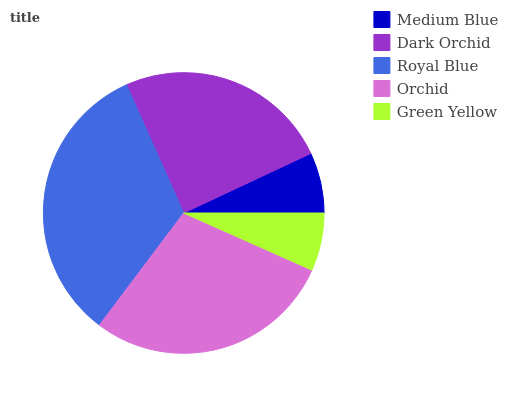Is Green Yellow the minimum?
Answer yes or no. Yes. Is Royal Blue the maximum?
Answer yes or no. Yes. Is Dark Orchid the minimum?
Answer yes or no. No. Is Dark Orchid the maximum?
Answer yes or no. No. Is Dark Orchid greater than Medium Blue?
Answer yes or no. Yes. Is Medium Blue less than Dark Orchid?
Answer yes or no. Yes. Is Medium Blue greater than Dark Orchid?
Answer yes or no. No. Is Dark Orchid less than Medium Blue?
Answer yes or no. No. Is Dark Orchid the high median?
Answer yes or no. Yes. Is Dark Orchid the low median?
Answer yes or no. Yes. Is Medium Blue the high median?
Answer yes or no. No. Is Medium Blue the low median?
Answer yes or no. No. 